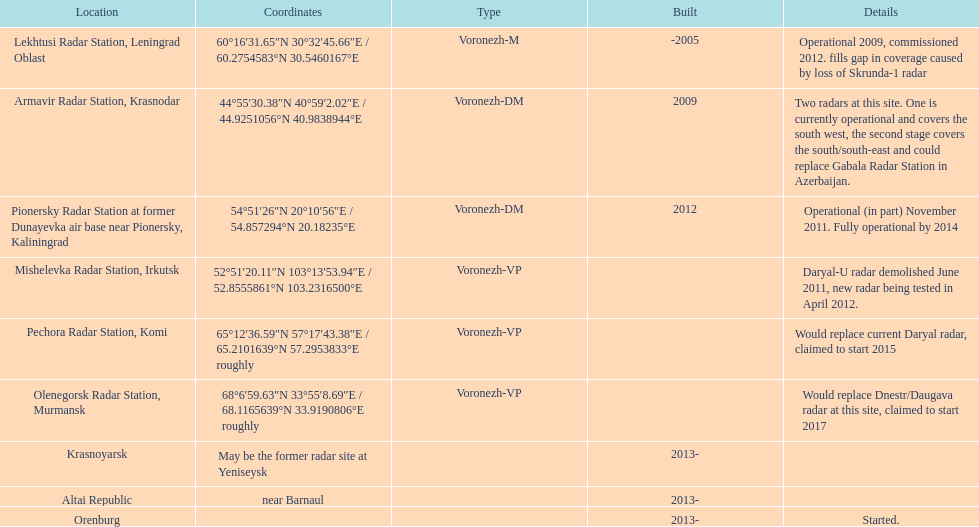How many voronezh radars are in kaliningrad or in krasnodar? 2. I'm looking to parse the entire table for insights. Could you assist me with that? {'header': ['Location', 'Coordinates', 'Type', 'Built', 'Details'], 'rows': [['Lekhtusi Radar Station, Leningrad Oblast', '60°16′31.65″N 30°32′45.66″E\ufeff / \ufeff60.2754583°N 30.5460167°E', 'Voronezh-M', '-2005', 'Operational 2009, commissioned 2012. fills gap in coverage caused by loss of Skrunda-1 radar'], ['Armavir Radar Station, Krasnodar', '44°55′30.38″N 40°59′2.02″E\ufeff / \ufeff44.9251056°N 40.9838944°E', 'Voronezh-DM', '2009', 'Two radars at this site. One is currently operational and covers the south west, the second stage covers the south/south-east and could replace Gabala Radar Station in Azerbaijan.'], ['Pionersky Radar Station at former Dunayevka air base near Pionersky, Kaliningrad', '54°51′26″N 20°10′56″E\ufeff / \ufeff54.857294°N 20.18235°E', 'Voronezh-DM', '2012', 'Operational (in part) November 2011. Fully operational by 2014'], ['Mishelevka Radar Station, Irkutsk', '52°51′20.11″N 103°13′53.94″E\ufeff / \ufeff52.8555861°N 103.2316500°E', 'Voronezh-VP', '', 'Daryal-U radar demolished June 2011, new radar being tested in April 2012.'], ['Pechora Radar Station, Komi', '65°12′36.59″N 57°17′43.38″E\ufeff / \ufeff65.2101639°N 57.2953833°E roughly', 'Voronezh-VP', '', 'Would replace current Daryal radar, claimed to start 2015'], ['Olenegorsk Radar Station, Murmansk', '68°6′59.63″N 33°55′8.69″E\ufeff / \ufeff68.1165639°N 33.9190806°E roughly', 'Voronezh-VP', '', 'Would replace Dnestr/Daugava radar at this site, claimed to start 2017'], ['Krasnoyarsk', 'May be the former radar site at Yeniseysk', '', '2013-', ''], ['Altai Republic', 'near Barnaul', '', '2013-', ''], ['Orenburg', '', '', '2013-', 'Started.']]} 